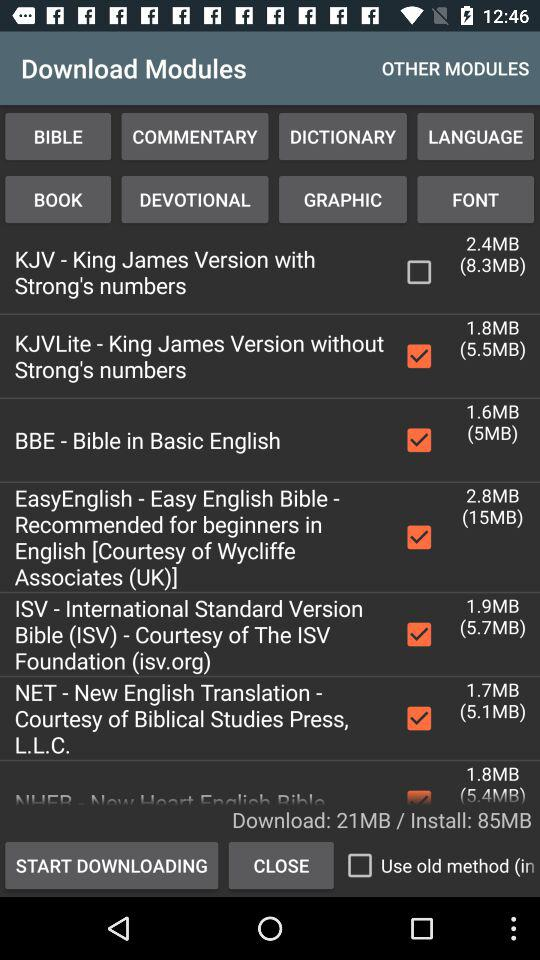How big is the installation? The installation is 85MB. 